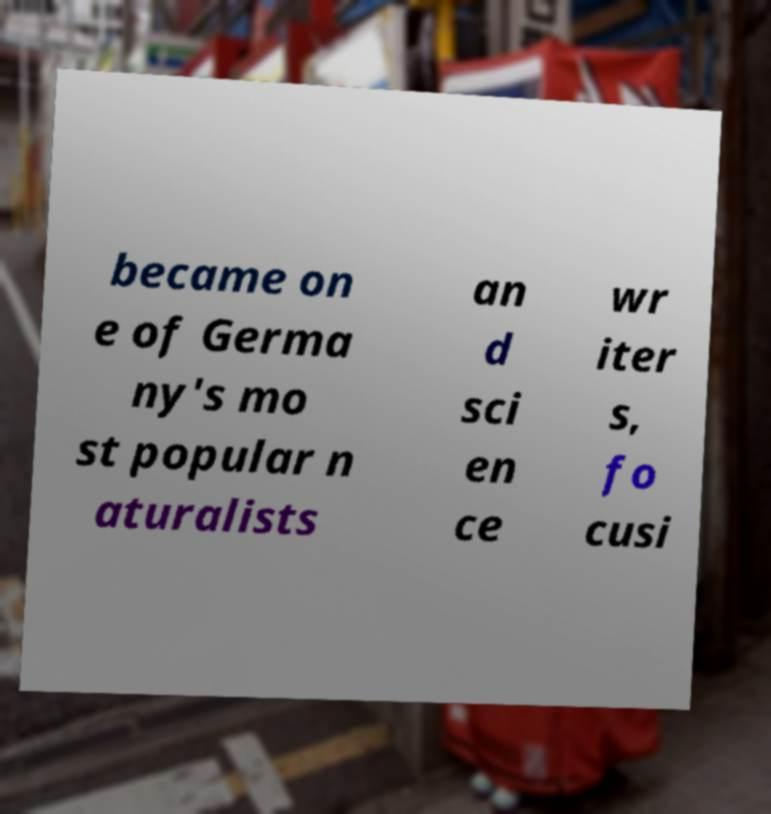There's text embedded in this image that I need extracted. Can you transcribe it verbatim? became on e of Germa ny's mo st popular n aturalists an d sci en ce wr iter s, fo cusi 